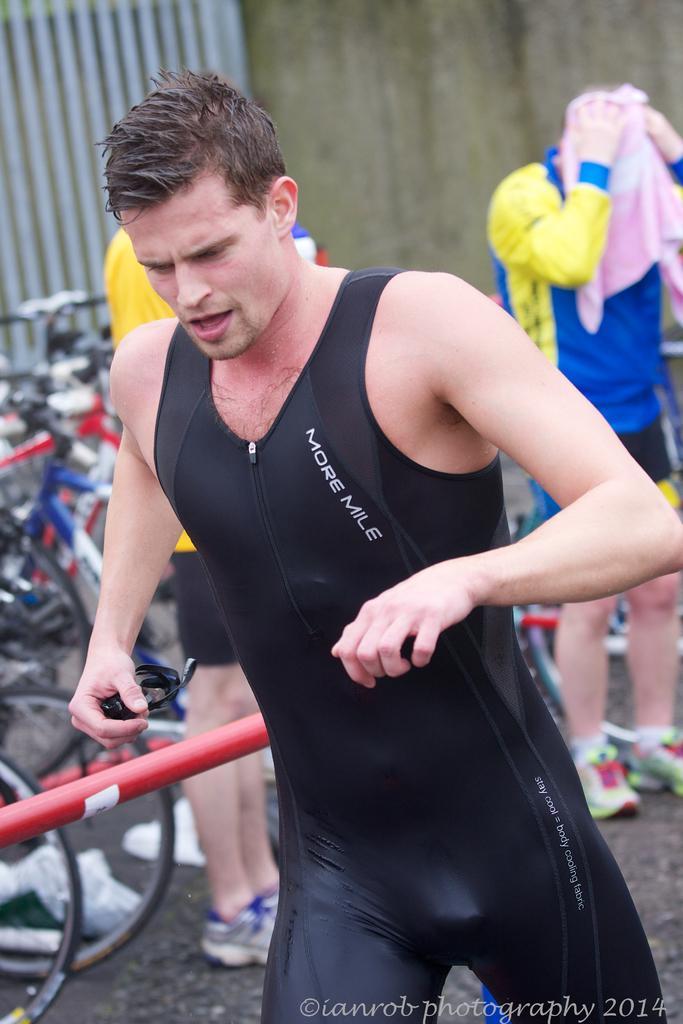How would you summarize this image in a sentence or two? There is a man in the picture who is wet and in swimsuit holding something in his hand. Behind him there are some persons, one is cleaning his head with a towel. He is wearing shoes. And the other guy is behind the man who is nearer to the picture. There is a railing rod behind the man and some cycles are parked there and in the background we can observe a wall and some rods. 